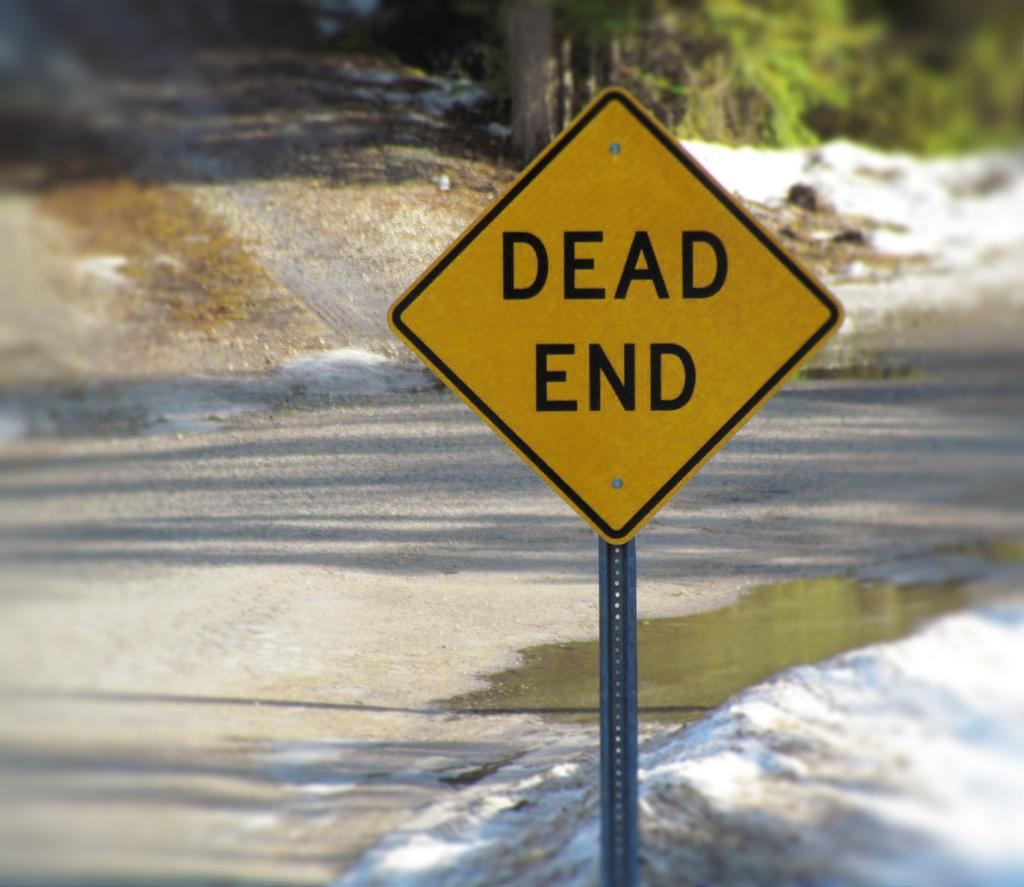<image>
Render a clear and concise summary of the photo. A yellow sign tells you the street is a dead end. 